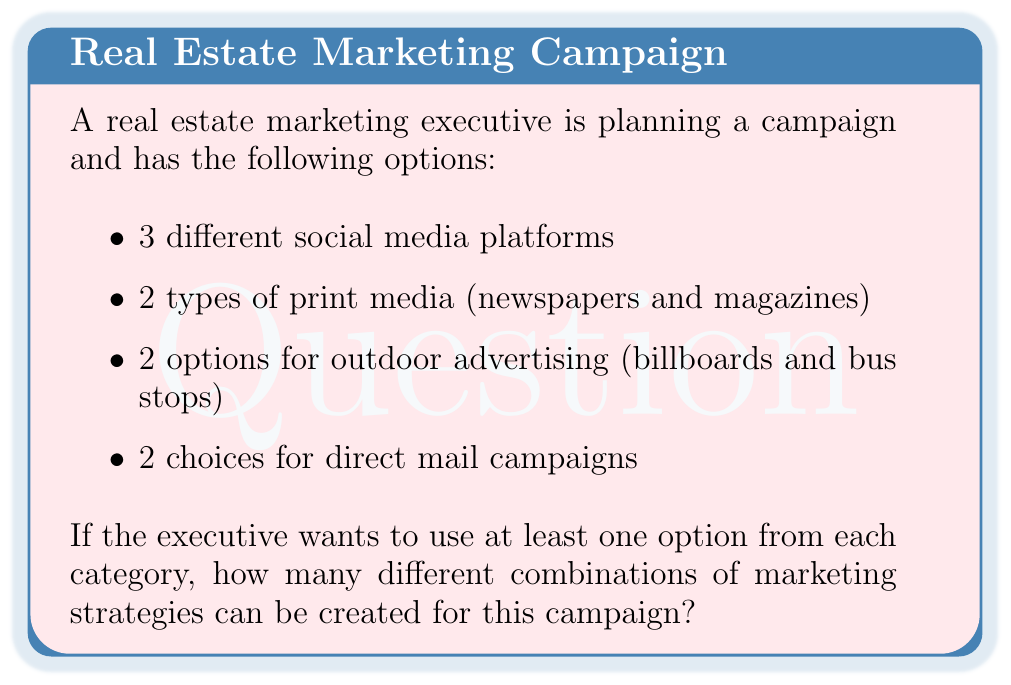Provide a solution to this math problem. Let's approach this step-by-step using the multiplication principle and the concept of subsets.

1) For each category, we have two possibilities: either we choose it or we don't, except for social media where we have more options.

2) Social media (3 options):
   We need to choose at least one, so we have $2^3 - 1 = 7$ possibilities
   (all combinations except choosing none)

3) Print media (2 options):
   We must choose at least one, so we have $2^2 - 1 = 3$ possibilities

4) Outdoor advertising (2 options):
   We must choose at least one, so we have $2^2 - 1 = 3$ possibilities

5) Direct mail (2 options):
   We must choose at least one, so we have $2^2 - 1 = 3$ possibilities

6) Now, we apply the multiplication principle. The total number of combinations is:

   $$ 7 \times 3 \times 3 \times 3 = 189 $$

Therefore, there are 189 different combinations of marketing strategies that use at least one option from each category.
Answer: 189 combinations 